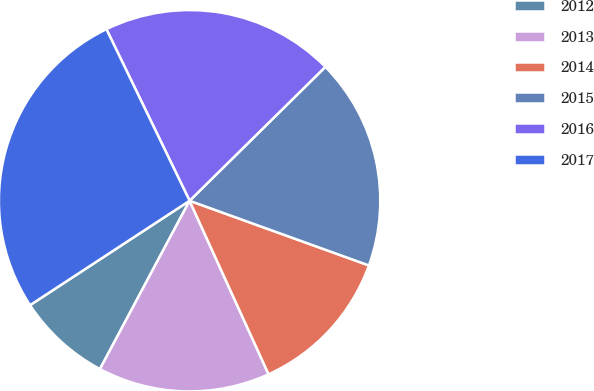Convert chart to OTSL. <chart><loc_0><loc_0><loc_500><loc_500><pie_chart><fcel>2012<fcel>2013<fcel>2014<fcel>2015<fcel>2016<fcel>2017<nl><fcel>7.99%<fcel>14.59%<fcel>12.69%<fcel>17.9%<fcel>19.8%<fcel>27.04%<nl></chart> 